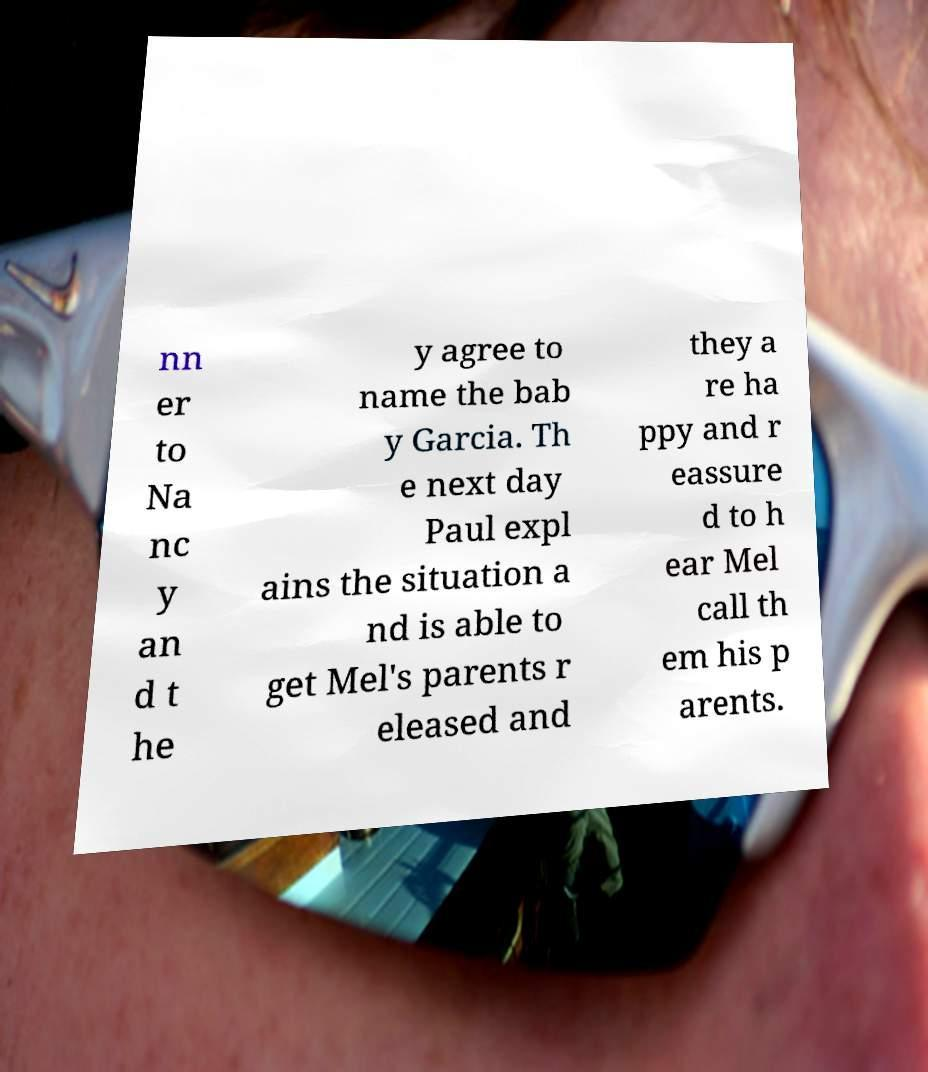For documentation purposes, I need the text within this image transcribed. Could you provide that? nn er to Na nc y an d t he y agree to name the bab y Garcia. Th e next day Paul expl ains the situation a nd is able to get Mel's parents r eleased and they a re ha ppy and r eassure d to h ear Mel call th em his p arents. 